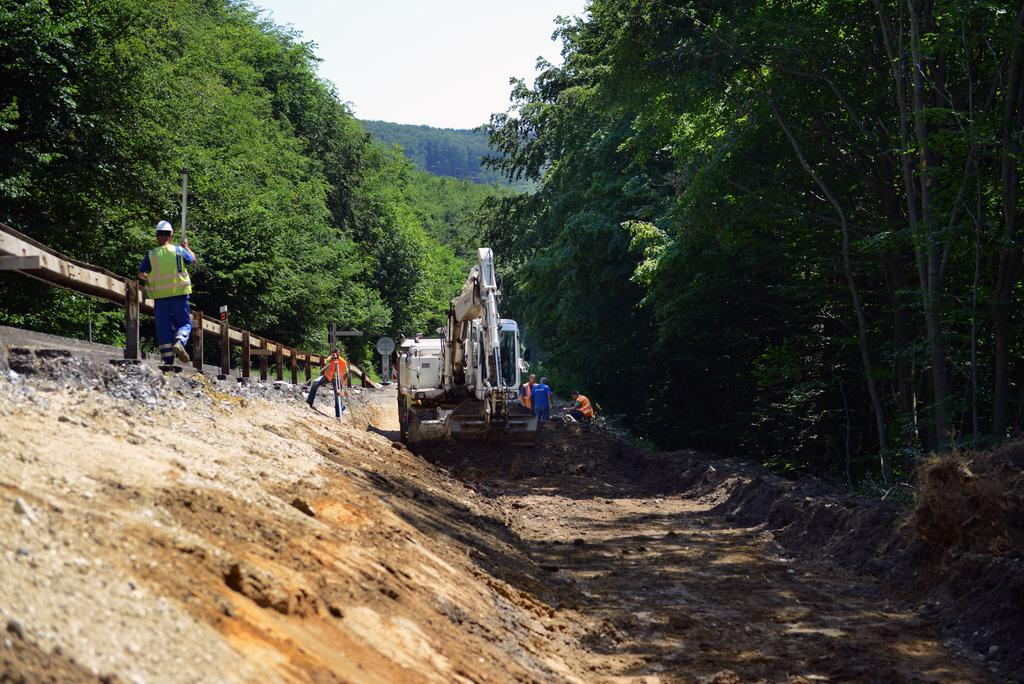What is the main subject in the center of the image? There is a crane in the center of the image. Can you describe the people in the image? There are people in the image, but their specific actions or positions are not mentioned in the facts. What is on the left side of the image? There is a fence on the left side of the image. What can be seen in the background of the image? There are trees and the sky visible in the background of the image. What type of vase is being used to hold the corn in the image? There is no vase or corn present in the image; it features a crane, people, a fence, trees, and the sky. 